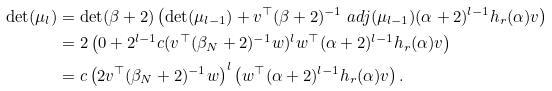<formula> <loc_0><loc_0><loc_500><loc_500>\det ( \mu _ { l } ) & = \det ( \beta + 2 ) \left ( \det ( \mu _ { l - 1 } ) + v ^ { \top } ( \beta + 2 ) ^ { - 1 } \ a d j ( \mu _ { l - 1 } ) ( \alpha + 2 ) ^ { l - 1 } h _ { r } ( \alpha ) v \right ) \\ & = 2 \left ( 0 + 2 ^ { l - 1 } c ( v ^ { \top } ( \beta _ { N } + 2 ) ^ { - 1 } w ) ^ { l } w ^ { \top } ( \alpha + 2 ) ^ { l - 1 } h _ { r } ( \alpha ) v \right ) \\ & = c \left ( 2 v ^ { \top } ( \beta _ { N } + 2 ) ^ { - 1 } w \right ) ^ { l } \left ( w ^ { \top } ( \alpha + 2 ) ^ { l - 1 } h _ { r } ( \alpha ) v \right ) .</formula> 